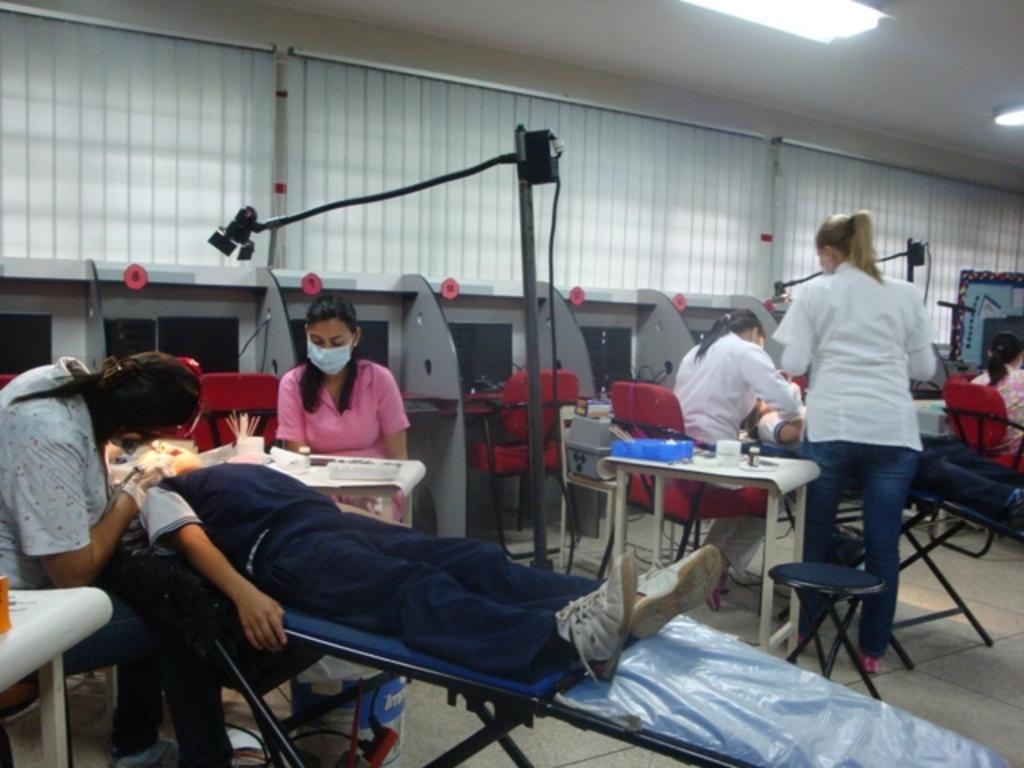Please provide a concise description of this image. In this image I can see few people. Some people are sitting on the chair. At the top there is a light to the ceiling. 